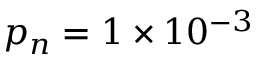Convert formula to latex. <formula><loc_0><loc_0><loc_500><loc_500>p _ { n } = 1 \times 1 0 ^ { - 3 }</formula> 